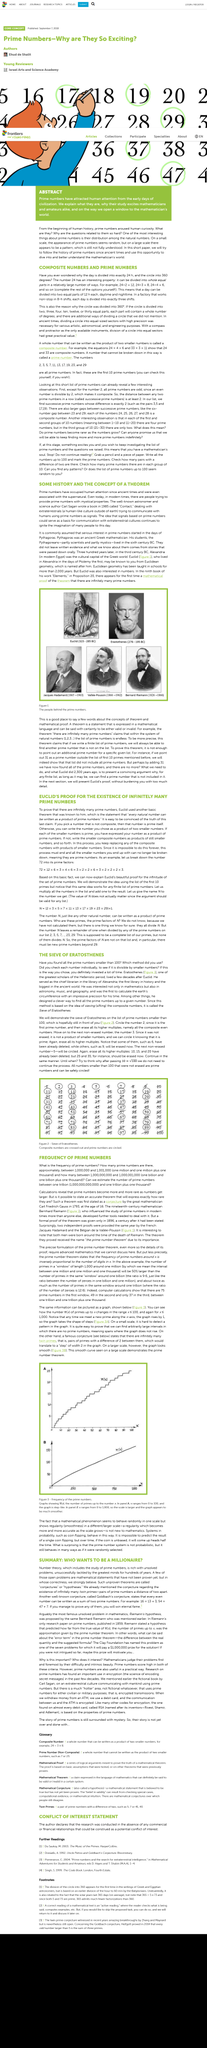Draw attention to some important aspects in this diagram. By utilizing a 24-hour clock, a factory can effectively manage three eight-hour shifts. Solving or proving a mathematical hypothesis can result in eternal fame and a monetary reward of one million dollars. The text describes the existence of infinitely many twin prime numbers and Goldbach's conjecture. The Goldbach hypothesis states that every even number is the sum of two prime numbers. This conjecture has yet to be proven or disproven. The article poses three questions. 